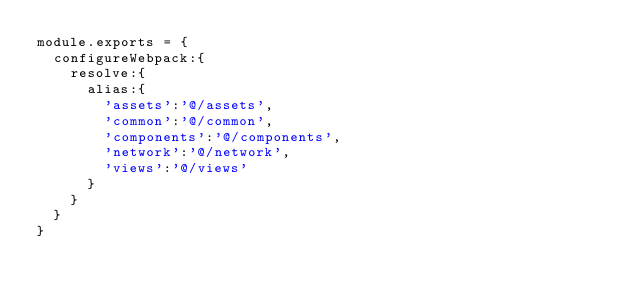Convert code to text. <code><loc_0><loc_0><loc_500><loc_500><_JavaScript_>module.exports = {
  configureWebpack:{
    resolve:{
      alias:{
        'assets':'@/assets',
        'common':'@/common',
        'components':'@/components',
        'network':'@/network',
        'views':'@/views'
      }
    }
  }
}
</code> 